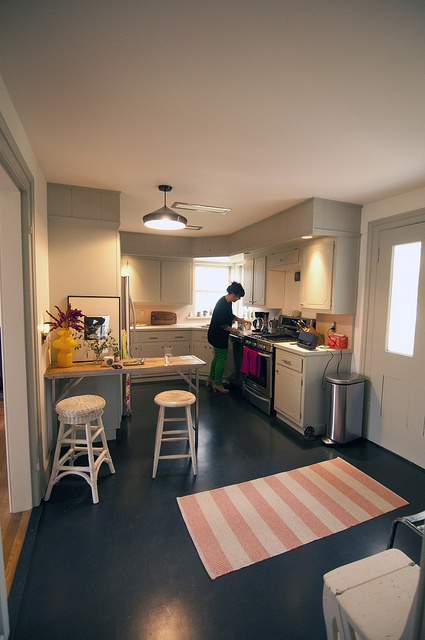Describe the objects in this image and their specific colors. I can see chair in black and gray tones, chair in black, gray, and tan tones, dining table in black, gray, tan, and red tones, oven in black, purple, and gray tones, and people in black, maroon, gray, and brown tones in this image. 